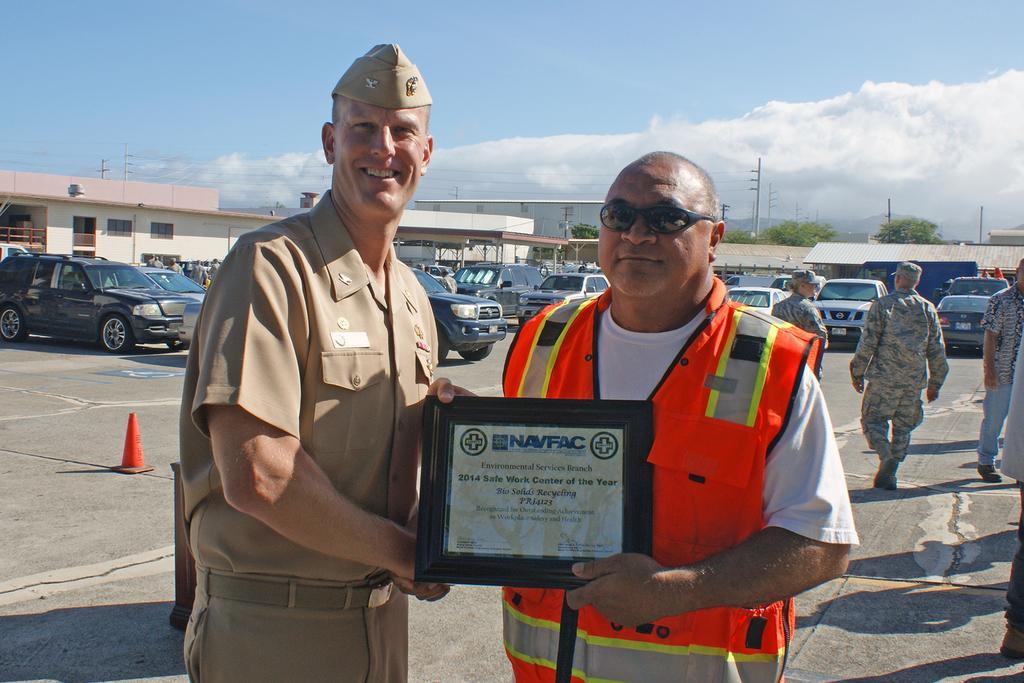How would you summarize this image in a sentence or two? In this image I can see people are standing among them the people in the front are standing and holding something in their hands. In the background I can see vehicles, buildings, poles which has wires and the sky. 